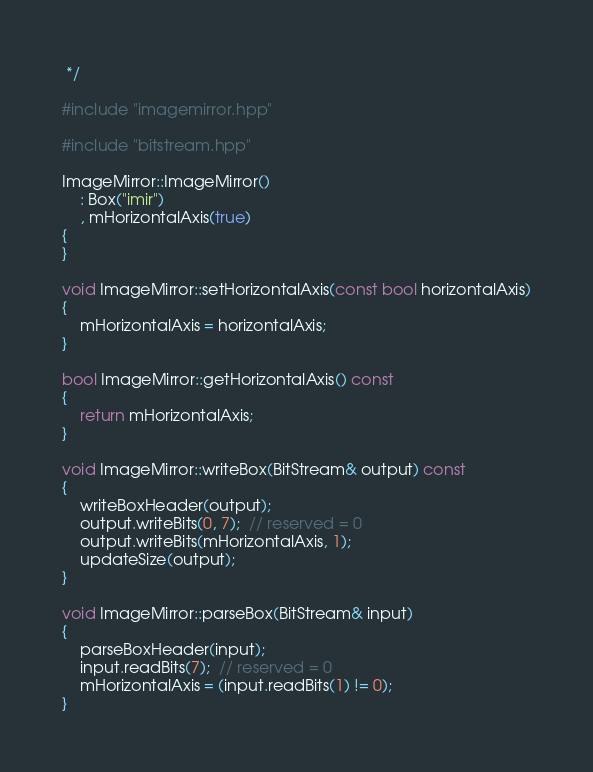<code> <loc_0><loc_0><loc_500><loc_500><_C++_> */

#include "imagemirror.hpp"

#include "bitstream.hpp"

ImageMirror::ImageMirror()
    : Box("imir")
    , mHorizontalAxis(true)
{
}

void ImageMirror::setHorizontalAxis(const bool horizontalAxis)
{
    mHorizontalAxis = horizontalAxis;
}

bool ImageMirror::getHorizontalAxis() const
{
    return mHorizontalAxis;
}

void ImageMirror::writeBox(BitStream& output) const
{
    writeBoxHeader(output);
    output.writeBits(0, 7);  // reserved = 0
    output.writeBits(mHorizontalAxis, 1);
    updateSize(output);
}

void ImageMirror::parseBox(BitStream& input)
{
    parseBoxHeader(input);
    input.readBits(7);  // reserved = 0
    mHorizontalAxis = (input.readBits(1) != 0);
}
</code> 